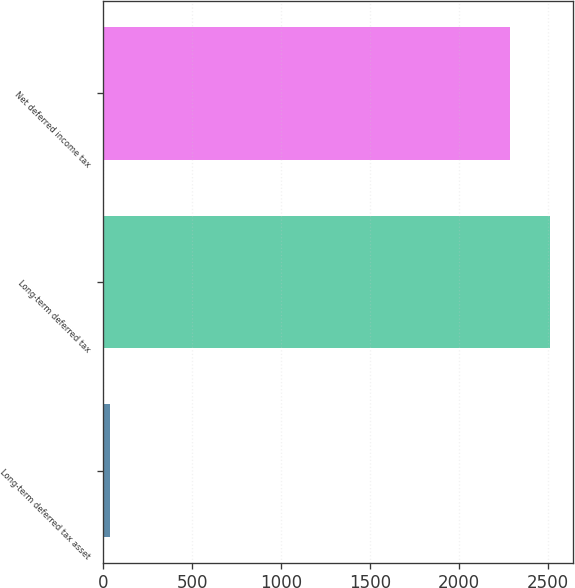<chart> <loc_0><loc_0><loc_500><loc_500><bar_chart><fcel>Long-term deferred tax asset<fcel>Long-term deferred tax<fcel>Net deferred income tax<nl><fcel>35.2<fcel>2514.93<fcel>2286.3<nl></chart> 